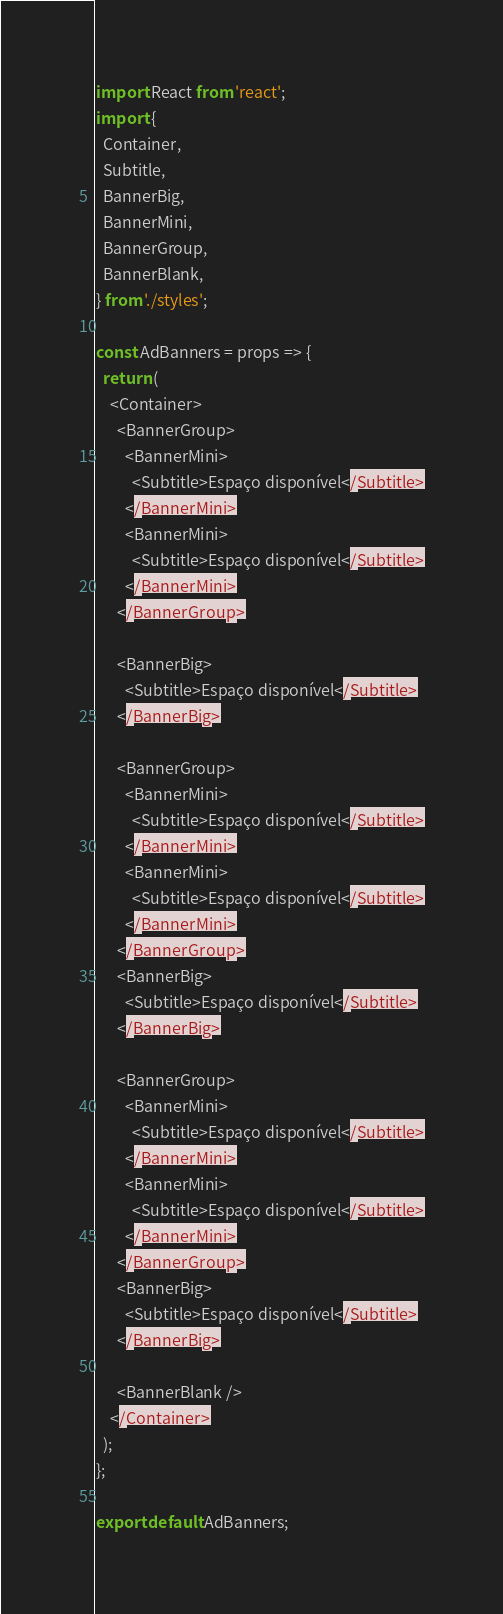<code> <loc_0><loc_0><loc_500><loc_500><_JavaScript_>import React from 'react';
import {
  Container,
  Subtitle,
  BannerBig,
  BannerMini,
  BannerGroup,
  BannerBlank,
} from './styles';

const AdBanners = props => {
  return (
    <Container>
      <BannerGroup>
        <BannerMini>
          <Subtitle>Espaço disponível</Subtitle>
        </BannerMini>
        <BannerMini>
          <Subtitle>Espaço disponível</Subtitle>
        </BannerMini>
      </BannerGroup>

      <BannerBig>
        <Subtitle>Espaço disponível</Subtitle>
      </BannerBig>

      <BannerGroup>
        <BannerMini>
          <Subtitle>Espaço disponível</Subtitle>
        </BannerMini>
        <BannerMini>
          <Subtitle>Espaço disponível</Subtitle>
        </BannerMini>
      </BannerGroup>
      <BannerBig>
        <Subtitle>Espaço disponível</Subtitle>
      </BannerBig>

      <BannerGroup>
        <BannerMini>
          <Subtitle>Espaço disponível</Subtitle>
        </BannerMini>
        <BannerMini>
          <Subtitle>Espaço disponível</Subtitle>
        </BannerMini>
      </BannerGroup>
      <BannerBig>
        <Subtitle>Espaço disponível</Subtitle>
      </BannerBig>

      <BannerBlank />
    </Container>
  );
};

export default AdBanners;
</code> 